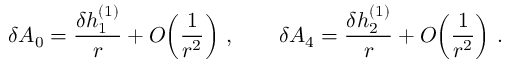<formula> <loc_0><loc_0><loc_500><loc_500>\delta A _ { 0 } = { \frac { \delta h _ { 1 } ^ { ( 1 ) } } { r } } + O \, \left ( { \frac { 1 } { r ^ { 2 } } } \right ) \, , \quad \delta A _ { 4 } = { \frac { \delta h _ { 2 } ^ { ( 1 ) } } { r } } + O \, \left ( { \frac { 1 } { r ^ { 2 } } } \right ) \, .</formula> 